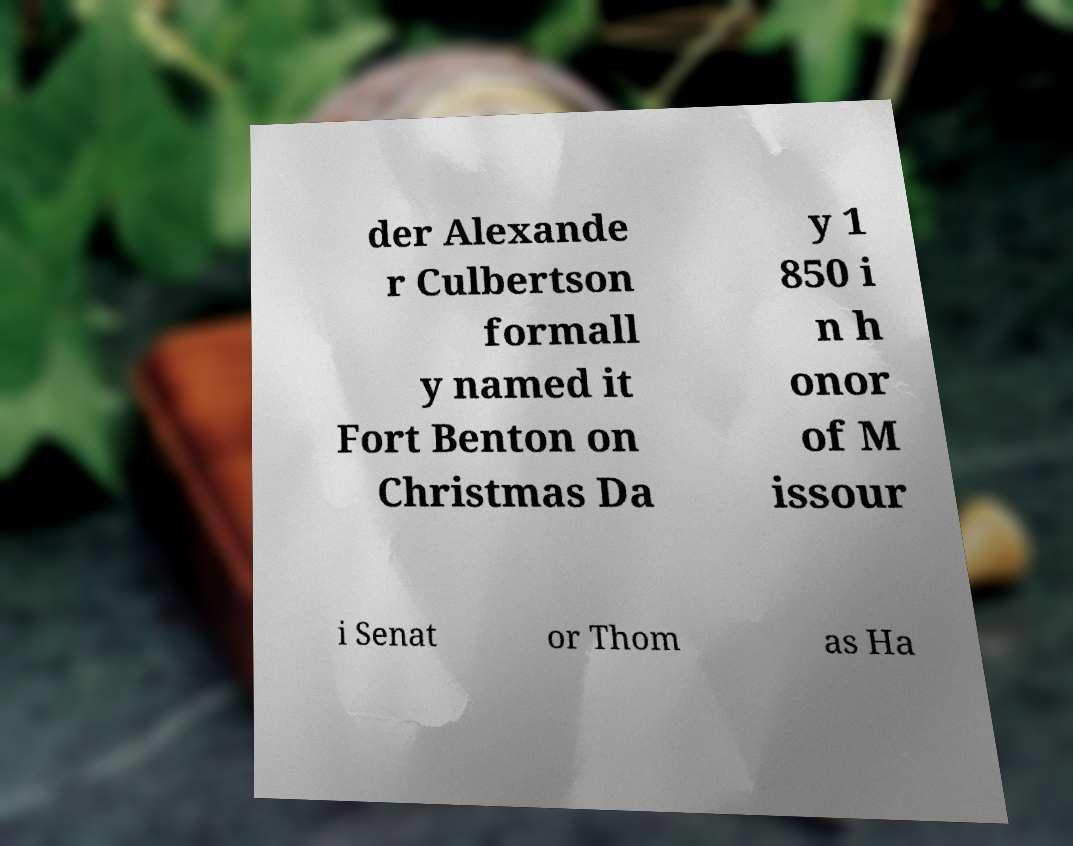Could you extract and type out the text from this image? der Alexande r Culbertson formall y named it Fort Benton on Christmas Da y 1 850 i n h onor of M issour i Senat or Thom as Ha 